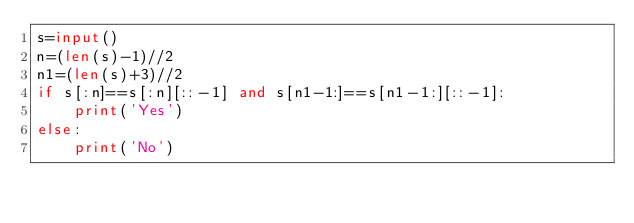<code> <loc_0><loc_0><loc_500><loc_500><_Python_>s=input()
n=(len(s)-1)//2
n1=(len(s)+3)//2
if s[:n]==s[:n][::-1] and s[n1-1:]==s[n1-1:][::-1]:
    print('Yes')
else:
    print('No')
</code> 